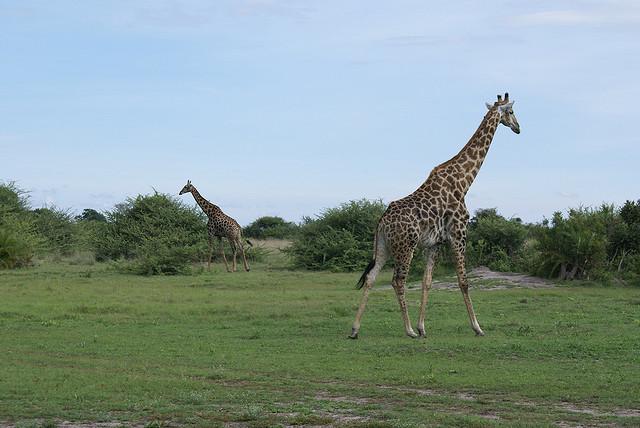How many trees?
Be succinct. 0. Are both giraffes adults?
Be succinct. Yes. What animals are these?
Short answer required. Giraffes. How many animals are at this location?
Quick response, please. 2. Are there clouds?
Concise answer only. Yes. Does the animal have a long tail?
Answer briefly. Yes. Was it taken in a ZOO?
Be succinct. No. Is the giraffe standing in grass?
Be succinct. Yes. 